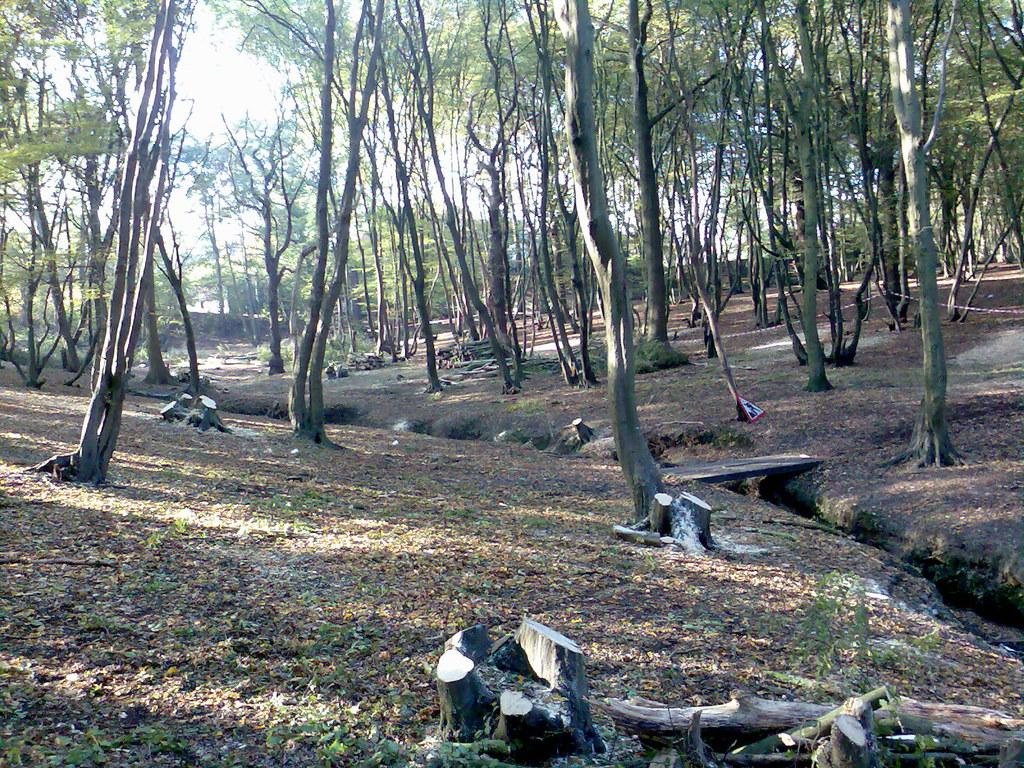What type of vegetation is visible in the image? There are trees in the image. What type of ground cover is present in the image? There is grass in the image. What can be observed about the lighting in the image? There are shadows in the image. What is the limit of the basketball court in the image? There is no basketball court present in the image. How many heads can be seen in the image? There are no heads visible in the image. 